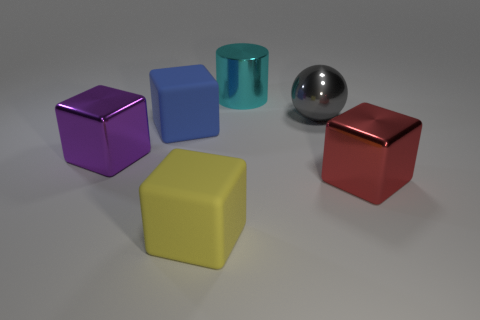What color is the metallic cylinder that is the same size as the gray ball?
Your answer should be very brief. Cyan. What number of things are matte objects that are in front of the big purple thing or matte cubes in front of the blue rubber cube?
Keep it short and to the point. 1. Are there the same number of large gray spheres right of the big red cube and blocks?
Give a very brief answer. No. There is a matte object that is in front of the big purple metallic thing; is it the same size as the metal cube right of the large cyan metal cylinder?
Ensure brevity in your answer.  Yes. What number of other objects are there of the same size as the metallic ball?
Your answer should be compact. 5. Are there any red metal things left of the matte block that is in front of the thing that is to the left of the large blue matte block?
Make the answer very short. No. Is there any other thing that is the same color as the metal cylinder?
Offer a terse response. No. What is the size of the metal block on the left side of the gray metal sphere?
Give a very brief answer. Large. There is a matte object that is behind the big rubber block that is in front of the metallic block that is right of the big blue thing; what is its size?
Ensure brevity in your answer.  Large. There is a shiny block to the right of the big shiny object that is left of the metallic cylinder; what is its color?
Offer a very short reply. Red. 